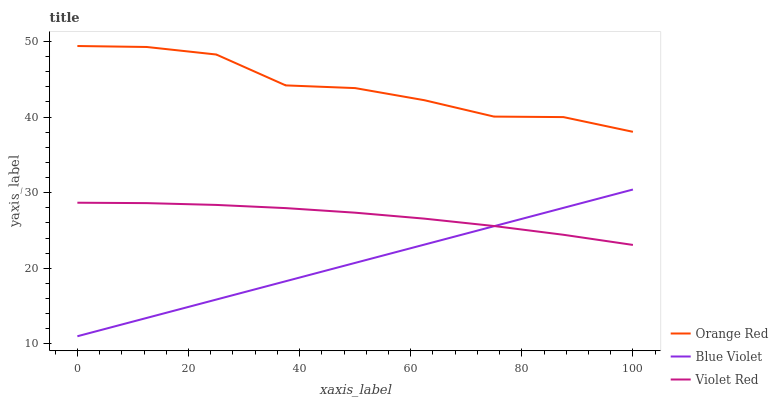Does Blue Violet have the minimum area under the curve?
Answer yes or no. Yes. Does Orange Red have the maximum area under the curve?
Answer yes or no. Yes. Does Orange Red have the minimum area under the curve?
Answer yes or no. No. Does Blue Violet have the maximum area under the curve?
Answer yes or no. No. Is Blue Violet the smoothest?
Answer yes or no. Yes. Is Orange Red the roughest?
Answer yes or no. Yes. Is Orange Red the smoothest?
Answer yes or no. No. Is Blue Violet the roughest?
Answer yes or no. No. Does Blue Violet have the lowest value?
Answer yes or no. Yes. Does Orange Red have the lowest value?
Answer yes or no. No. Does Orange Red have the highest value?
Answer yes or no. Yes. Does Blue Violet have the highest value?
Answer yes or no. No. Is Blue Violet less than Orange Red?
Answer yes or no. Yes. Is Orange Red greater than Violet Red?
Answer yes or no. Yes. Does Blue Violet intersect Violet Red?
Answer yes or no. Yes. Is Blue Violet less than Violet Red?
Answer yes or no. No. Is Blue Violet greater than Violet Red?
Answer yes or no. No. Does Blue Violet intersect Orange Red?
Answer yes or no. No. 